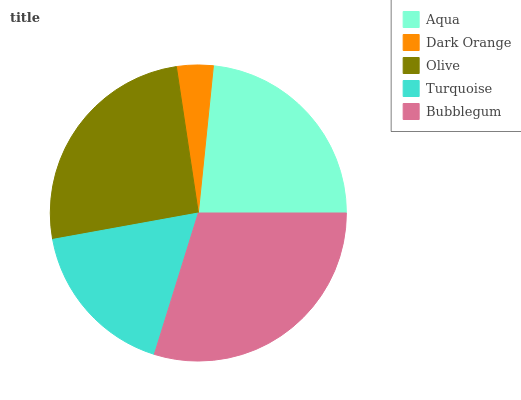Is Dark Orange the minimum?
Answer yes or no. Yes. Is Bubblegum the maximum?
Answer yes or no. Yes. Is Olive the minimum?
Answer yes or no. No. Is Olive the maximum?
Answer yes or no. No. Is Olive greater than Dark Orange?
Answer yes or no. Yes. Is Dark Orange less than Olive?
Answer yes or no. Yes. Is Dark Orange greater than Olive?
Answer yes or no. No. Is Olive less than Dark Orange?
Answer yes or no. No. Is Aqua the high median?
Answer yes or no. Yes. Is Aqua the low median?
Answer yes or no. Yes. Is Bubblegum the high median?
Answer yes or no. No. Is Olive the low median?
Answer yes or no. No. 